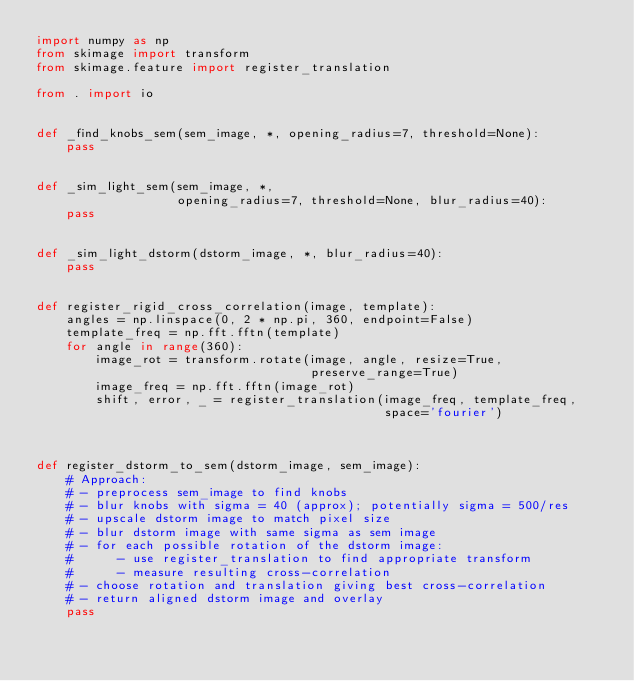Convert code to text. <code><loc_0><loc_0><loc_500><loc_500><_Python_>import numpy as np
from skimage import transform
from skimage.feature import register_translation

from . import io


def _find_knobs_sem(sem_image, *, opening_radius=7, threshold=None):
    pass


def _sim_light_sem(sem_image, *,
                   opening_radius=7, threshold=None, blur_radius=40):
    pass


def _sim_light_dstorm(dstorm_image, *, blur_radius=40):
    pass


def register_rigid_cross_correlation(image, template):
    angles = np.linspace(0, 2 * np.pi, 360, endpoint=False)
    template_freq = np.fft.fftn(template)
    for angle in range(360):
        image_rot = transform.rotate(image, angle, resize=True,
                                     preserve_range=True)
        image_freq = np.fft.fftn(image_rot)
        shift, error, _ = register_translation(image_freq, template_freq,
                                               space='fourier')



def register_dstorm_to_sem(dstorm_image, sem_image):
    # Approach:
    # - preprocess sem_image to find knobs
    # - blur knobs with sigma = 40 (approx); potentially sigma = 500/res
    # - upscale dstorm image to match pixel size
    # - blur dstorm image with same sigma as sem image
    # - for each possible rotation of the dstorm image:
    #      - use register_translation to find appropriate transform
    #      - measure resulting cross-correlation
    # - choose rotation and translation giving best cross-correlation
    # - return aligned dstorm image and overlay
    pass</code> 